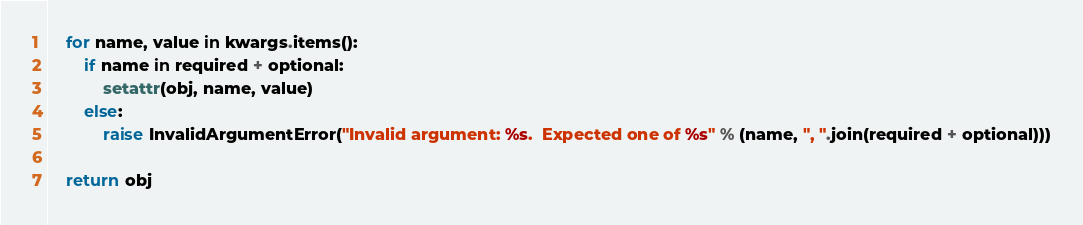Convert code to text. <code><loc_0><loc_0><loc_500><loc_500><_Python_>    for name, value in kwargs.items():
        if name in required + optional:
            setattr(obj, name, value)
        else:
            raise InvalidArgumentError("Invalid argument: %s.  Expected one of %s" % (name, ", ".join(required + optional)))

    return obj
</code> 